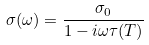<formula> <loc_0><loc_0><loc_500><loc_500>\sigma ( \omega ) = \frac { \sigma _ { 0 } } { 1 - i \omega \tau ( T ) }</formula> 